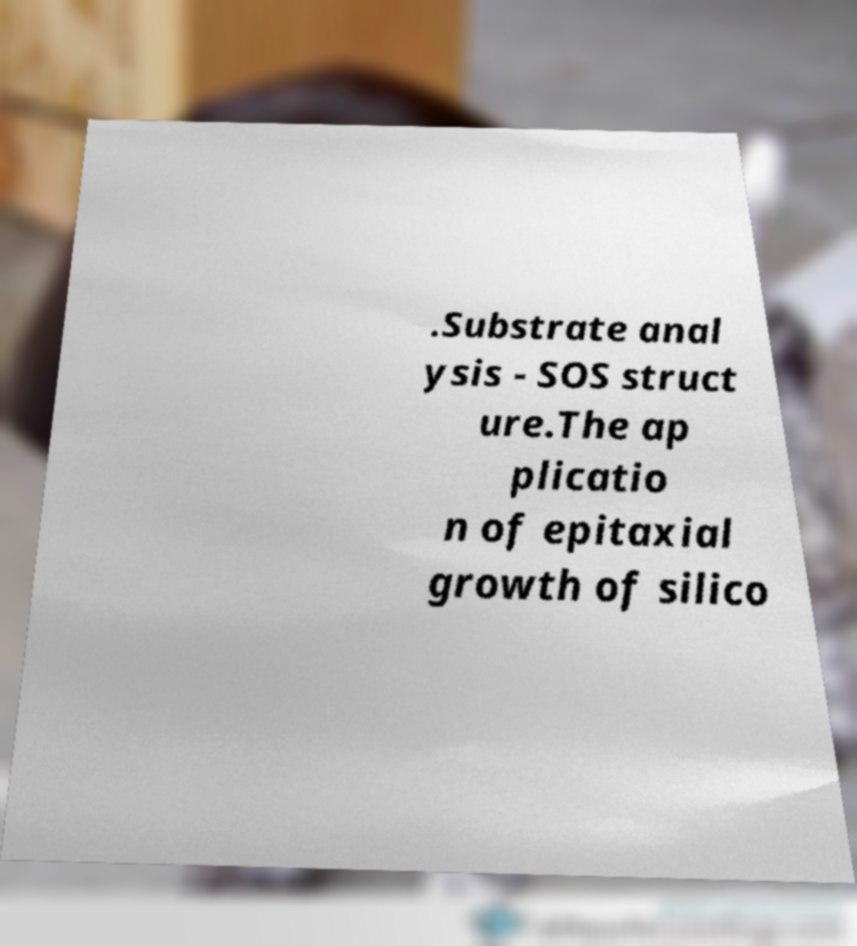Could you assist in decoding the text presented in this image and type it out clearly? .Substrate anal ysis - SOS struct ure.The ap plicatio n of epitaxial growth of silico 